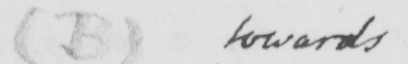What does this handwritten line say? ( B ) towards 